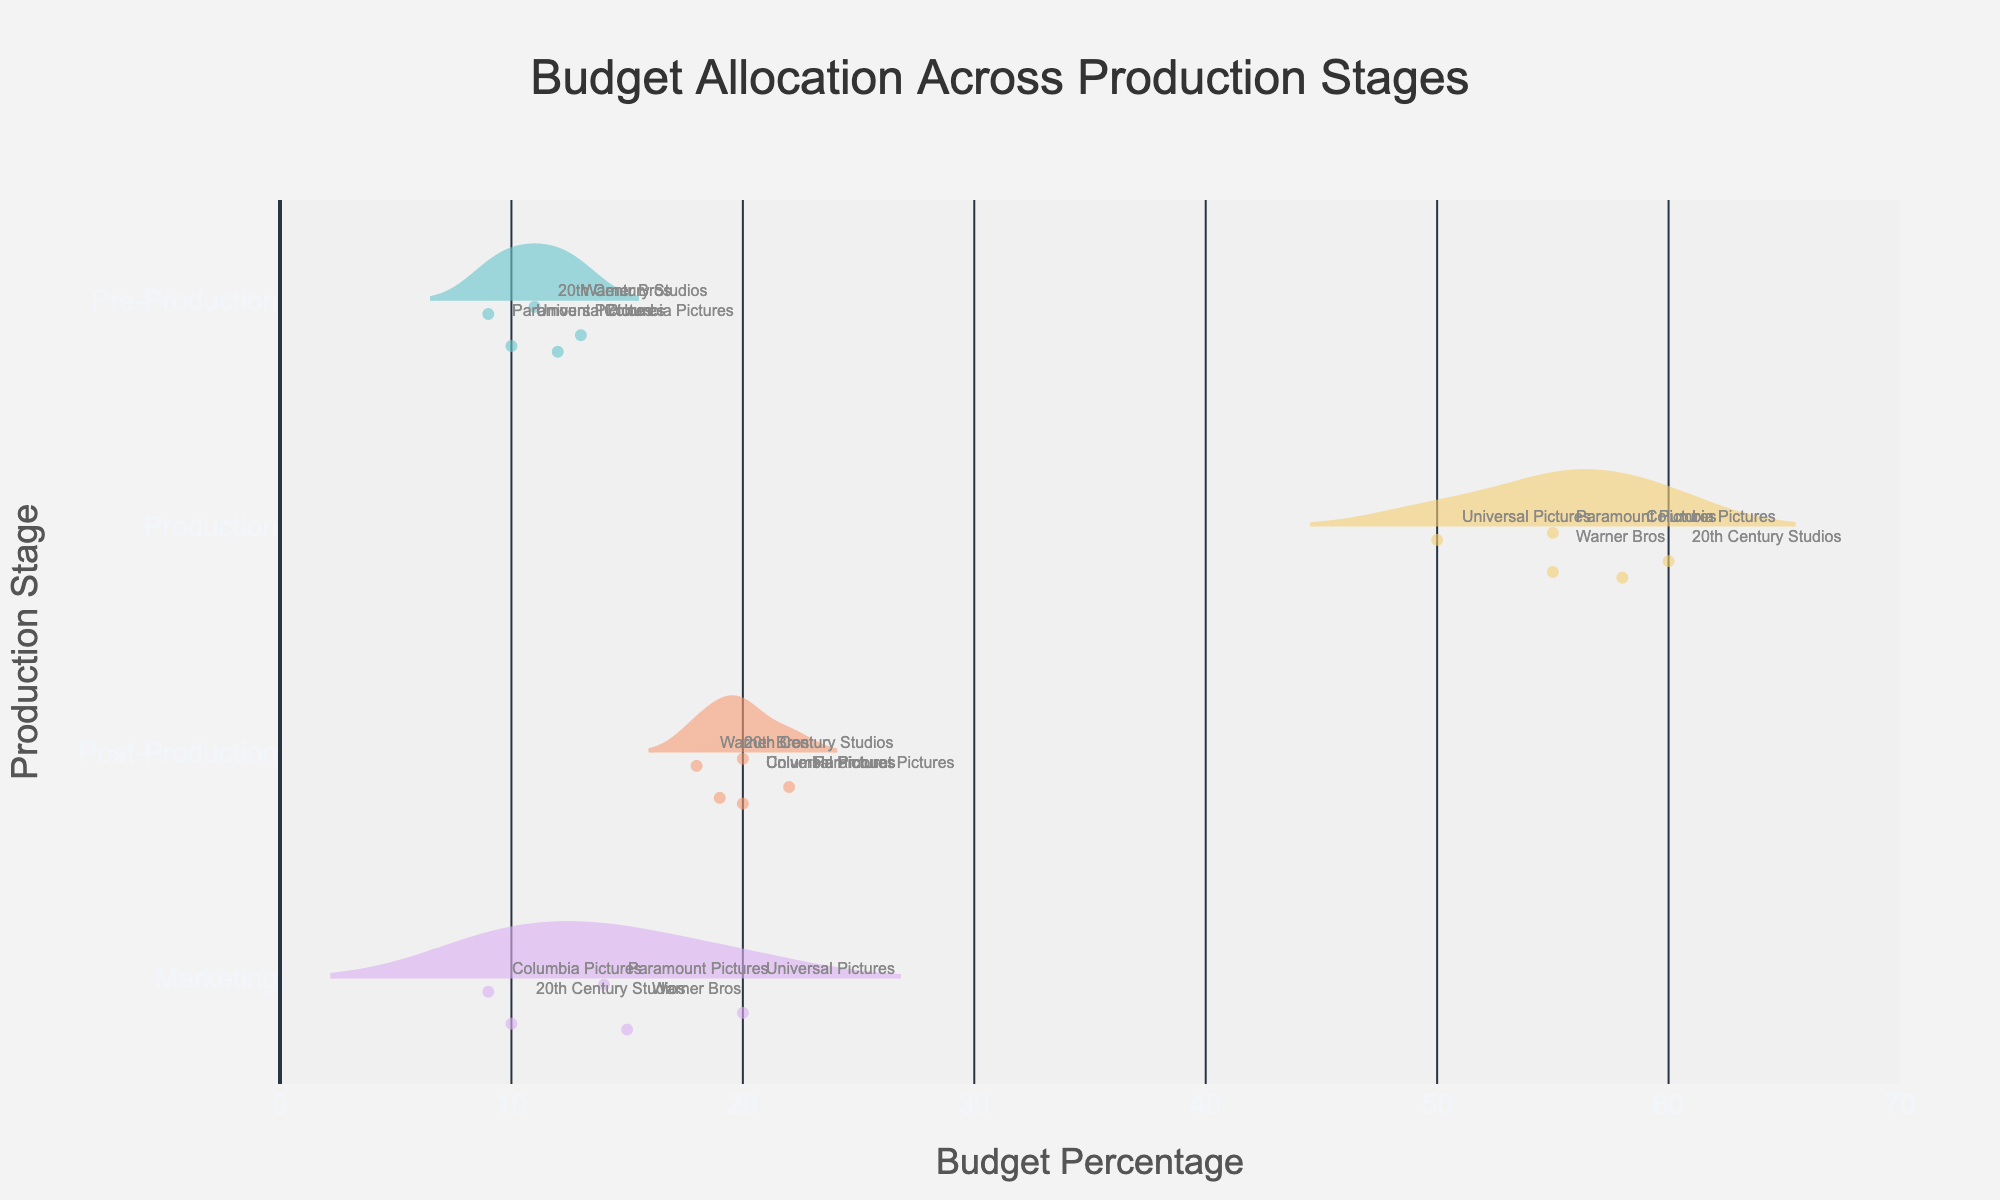What is the title of the figure? The title is typically located at the top center of the figure. The title of this figure is "Budget Allocation Across Production Stages".
Answer: Budget Allocation Across Production Stages Which production stage has the widest distribution in budget percentage? In a violin plot, the width of the distribution indicates the spread of the data. The Production stage shows the widest distribution, indicating it has the greatest variation in budget percentages among different studios.
Answer: Production What is the mean budget percentage for pre-production? To find the mean budget percentage, look at the meanline visible on the violin plot for Pre-Production. From the chart, the mean budget percentage is indicated by a line within the Pre-Production distribution.
Answer: Around 11% Which studio has the highest budget percentage during the production stage? The chart shows individual data points within each violin. For the Production stage, the data point furthest to the right represents the highest budget percentage, which is 20th Century Studios at 60%.
Answer: 20th Century Studios Which production stage has the least variation in budget allocation? The least variation is observed in the violin with the narrowest spread. In this case, the Marketing stage has the least variation in budget allocation as it has the narrowest distribution.
Answer: Marketing What is the median budget percentage for post-production? The median is typically represented by the central line in a box plot component of the violin chart. For Post-Production, the median line can be seen around the 20% mark.
Answer: 20% Compare the budget percentage for marketing between Universal Pictures and Columbia Pictures. Look at the data points for both studios within the Marketing stage. Universal Pictures allocates 20% while Columbia Pictures allocates 9%. Universal Pictures allocates a higher percentage.
Answer: Universal Pictures has a higher budget percentage What is the range of budget percentages for the Production stage? To determine the range, subtract the smallest value from the largest value in the Production stage. The budget percentages range from 50% to 60%, so the range is 60 - 50 = 10%.
Answer: 10% Which production stage has an outlier in budget allocation, and who does it belong to? An outlier is typically shown as a point outside the normal range of the plot. In the Marketing stage, Universal Pictures has an outlier budget percentage of 20%, significantly higher than others.
Answer: Marketing, Universal Pictures 